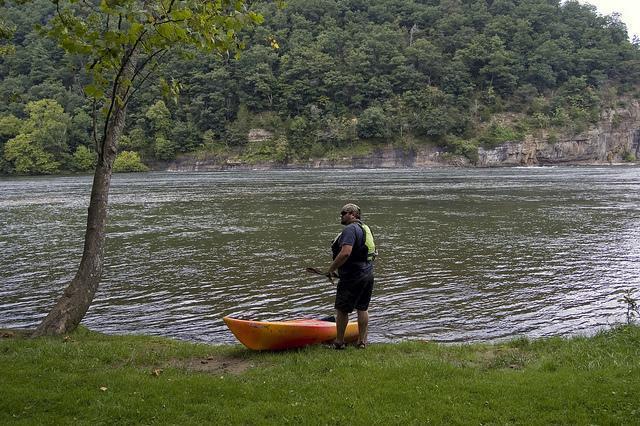How many people are in the shot?
Give a very brief answer. 1. 